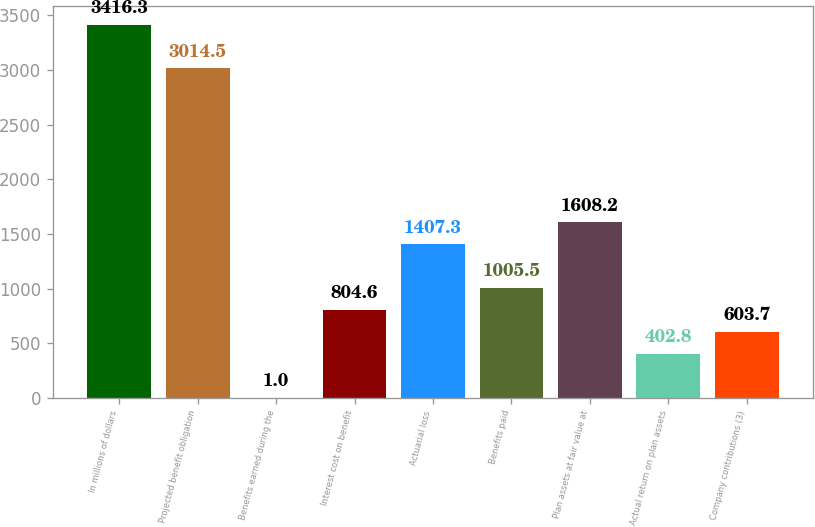Convert chart to OTSL. <chart><loc_0><loc_0><loc_500><loc_500><bar_chart><fcel>In millions of dollars<fcel>Projected benefit obligation<fcel>Benefits earned during the<fcel>Interest cost on benefit<fcel>Actuarial loss<fcel>Benefits paid<fcel>Plan assets at fair value at<fcel>Actual return on plan assets<fcel>Company contributions (3)<nl><fcel>3416.3<fcel>3014.5<fcel>1<fcel>804.6<fcel>1407.3<fcel>1005.5<fcel>1608.2<fcel>402.8<fcel>603.7<nl></chart> 